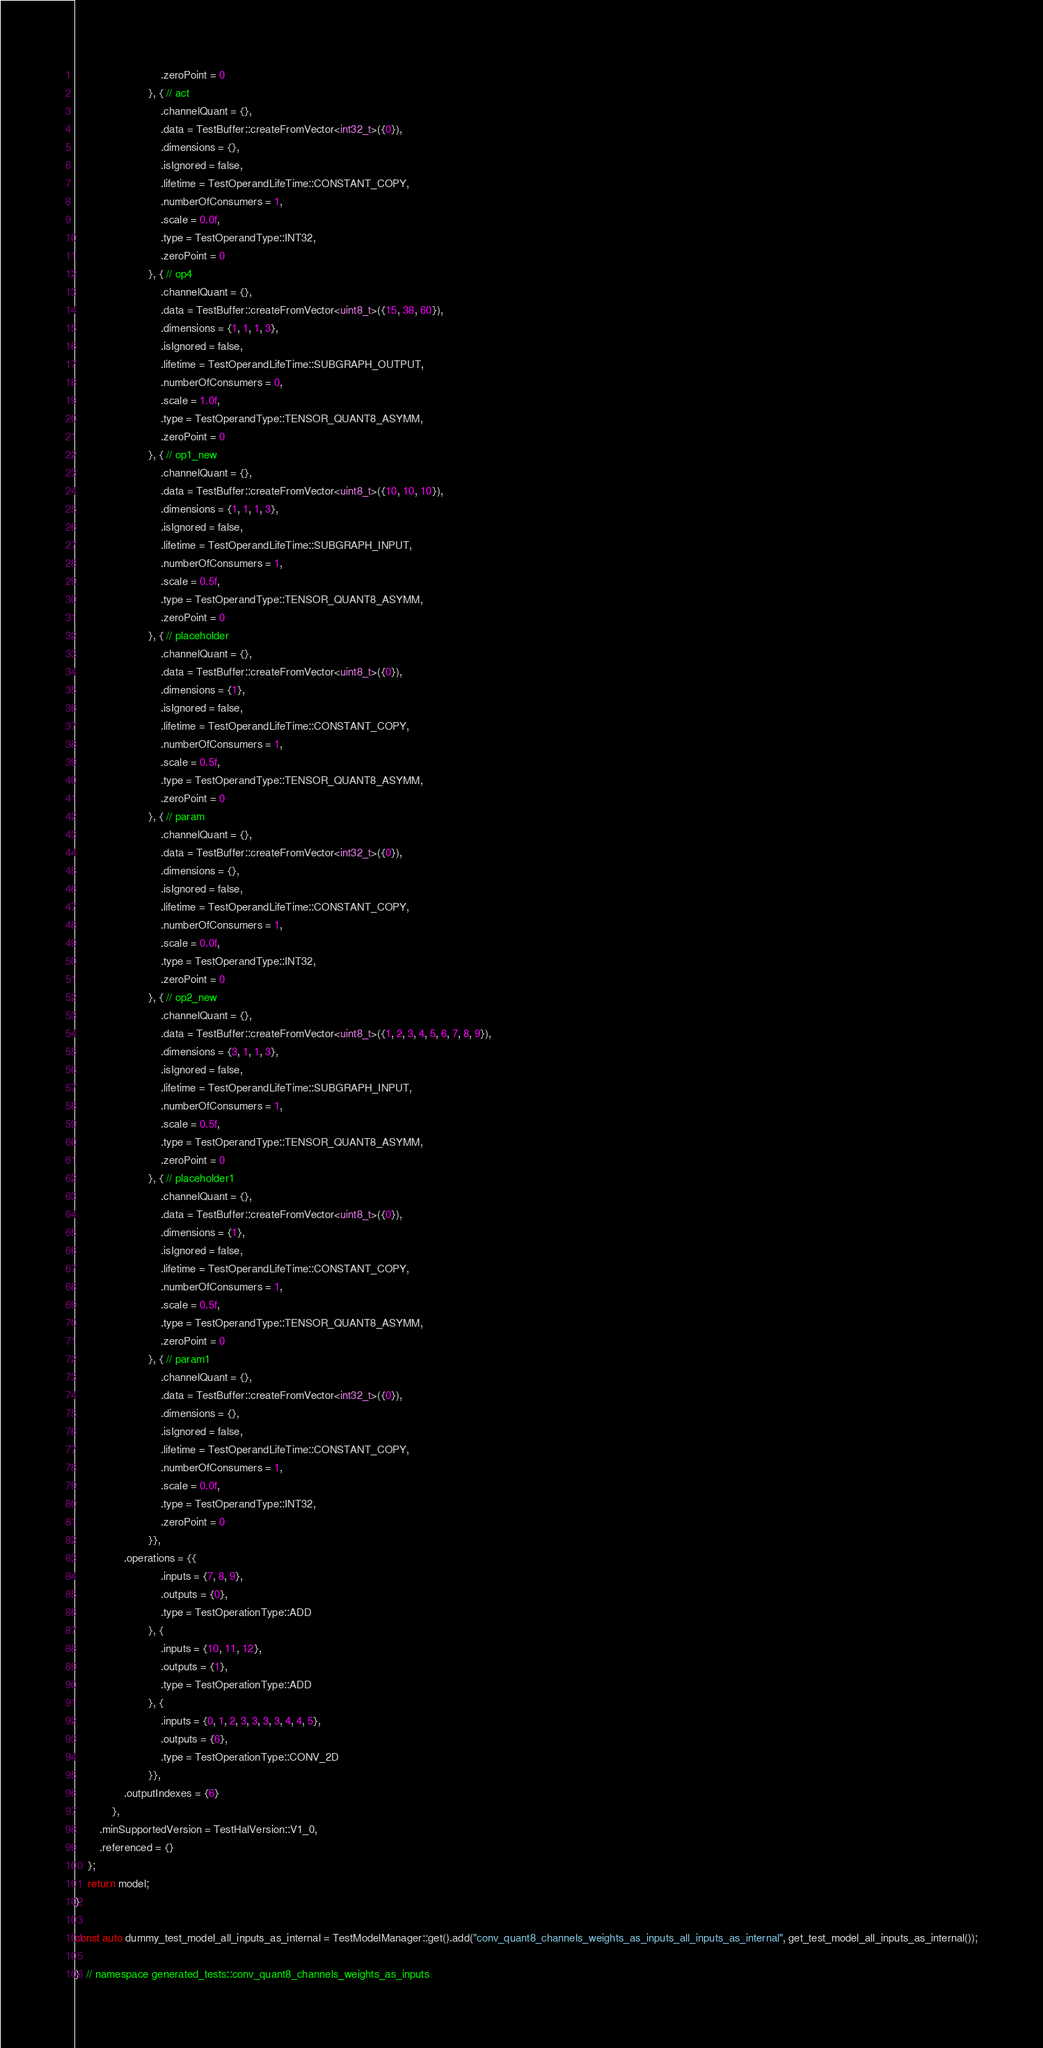<code> <loc_0><loc_0><loc_500><loc_500><_C++_>                            .zeroPoint = 0
                        }, { // act
                            .channelQuant = {},
                            .data = TestBuffer::createFromVector<int32_t>({0}),
                            .dimensions = {},
                            .isIgnored = false,
                            .lifetime = TestOperandLifeTime::CONSTANT_COPY,
                            .numberOfConsumers = 1,
                            .scale = 0.0f,
                            .type = TestOperandType::INT32,
                            .zeroPoint = 0
                        }, { // op4
                            .channelQuant = {},
                            .data = TestBuffer::createFromVector<uint8_t>({15, 38, 60}),
                            .dimensions = {1, 1, 1, 3},
                            .isIgnored = false,
                            .lifetime = TestOperandLifeTime::SUBGRAPH_OUTPUT,
                            .numberOfConsumers = 0,
                            .scale = 1.0f,
                            .type = TestOperandType::TENSOR_QUANT8_ASYMM,
                            .zeroPoint = 0
                        }, { // op1_new
                            .channelQuant = {},
                            .data = TestBuffer::createFromVector<uint8_t>({10, 10, 10}),
                            .dimensions = {1, 1, 1, 3},
                            .isIgnored = false,
                            .lifetime = TestOperandLifeTime::SUBGRAPH_INPUT,
                            .numberOfConsumers = 1,
                            .scale = 0.5f,
                            .type = TestOperandType::TENSOR_QUANT8_ASYMM,
                            .zeroPoint = 0
                        }, { // placeholder
                            .channelQuant = {},
                            .data = TestBuffer::createFromVector<uint8_t>({0}),
                            .dimensions = {1},
                            .isIgnored = false,
                            .lifetime = TestOperandLifeTime::CONSTANT_COPY,
                            .numberOfConsumers = 1,
                            .scale = 0.5f,
                            .type = TestOperandType::TENSOR_QUANT8_ASYMM,
                            .zeroPoint = 0
                        }, { // param
                            .channelQuant = {},
                            .data = TestBuffer::createFromVector<int32_t>({0}),
                            .dimensions = {},
                            .isIgnored = false,
                            .lifetime = TestOperandLifeTime::CONSTANT_COPY,
                            .numberOfConsumers = 1,
                            .scale = 0.0f,
                            .type = TestOperandType::INT32,
                            .zeroPoint = 0
                        }, { // op2_new
                            .channelQuant = {},
                            .data = TestBuffer::createFromVector<uint8_t>({1, 2, 3, 4, 5, 6, 7, 8, 9}),
                            .dimensions = {3, 1, 1, 3},
                            .isIgnored = false,
                            .lifetime = TestOperandLifeTime::SUBGRAPH_INPUT,
                            .numberOfConsumers = 1,
                            .scale = 0.5f,
                            .type = TestOperandType::TENSOR_QUANT8_ASYMM,
                            .zeroPoint = 0
                        }, { // placeholder1
                            .channelQuant = {},
                            .data = TestBuffer::createFromVector<uint8_t>({0}),
                            .dimensions = {1},
                            .isIgnored = false,
                            .lifetime = TestOperandLifeTime::CONSTANT_COPY,
                            .numberOfConsumers = 1,
                            .scale = 0.5f,
                            .type = TestOperandType::TENSOR_QUANT8_ASYMM,
                            .zeroPoint = 0
                        }, { // param1
                            .channelQuant = {},
                            .data = TestBuffer::createFromVector<int32_t>({0}),
                            .dimensions = {},
                            .isIgnored = false,
                            .lifetime = TestOperandLifeTime::CONSTANT_COPY,
                            .numberOfConsumers = 1,
                            .scale = 0.0f,
                            .type = TestOperandType::INT32,
                            .zeroPoint = 0
                        }},
                .operations = {{
                            .inputs = {7, 8, 9},
                            .outputs = {0},
                            .type = TestOperationType::ADD
                        }, {
                            .inputs = {10, 11, 12},
                            .outputs = {1},
                            .type = TestOperationType::ADD
                        }, {
                            .inputs = {0, 1, 2, 3, 3, 3, 3, 4, 4, 5},
                            .outputs = {6},
                            .type = TestOperationType::CONV_2D
                        }},
                .outputIndexes = {6}
            },
        .minSupportedVersion = TestHalVersion::V1_0,
        .referenced = {}
    };
    return model;
}

const auto dummy_test_model_all_inputs_as_internal = TestModelManager::get().add("conv_quant8_channels_weights_as_inputs_all_inputs_as_internal", get_test_model_all_inputs_as_internal());

}  // namespace generated_tests::conv_quant8_channels_weights_as_inputs

</code> 